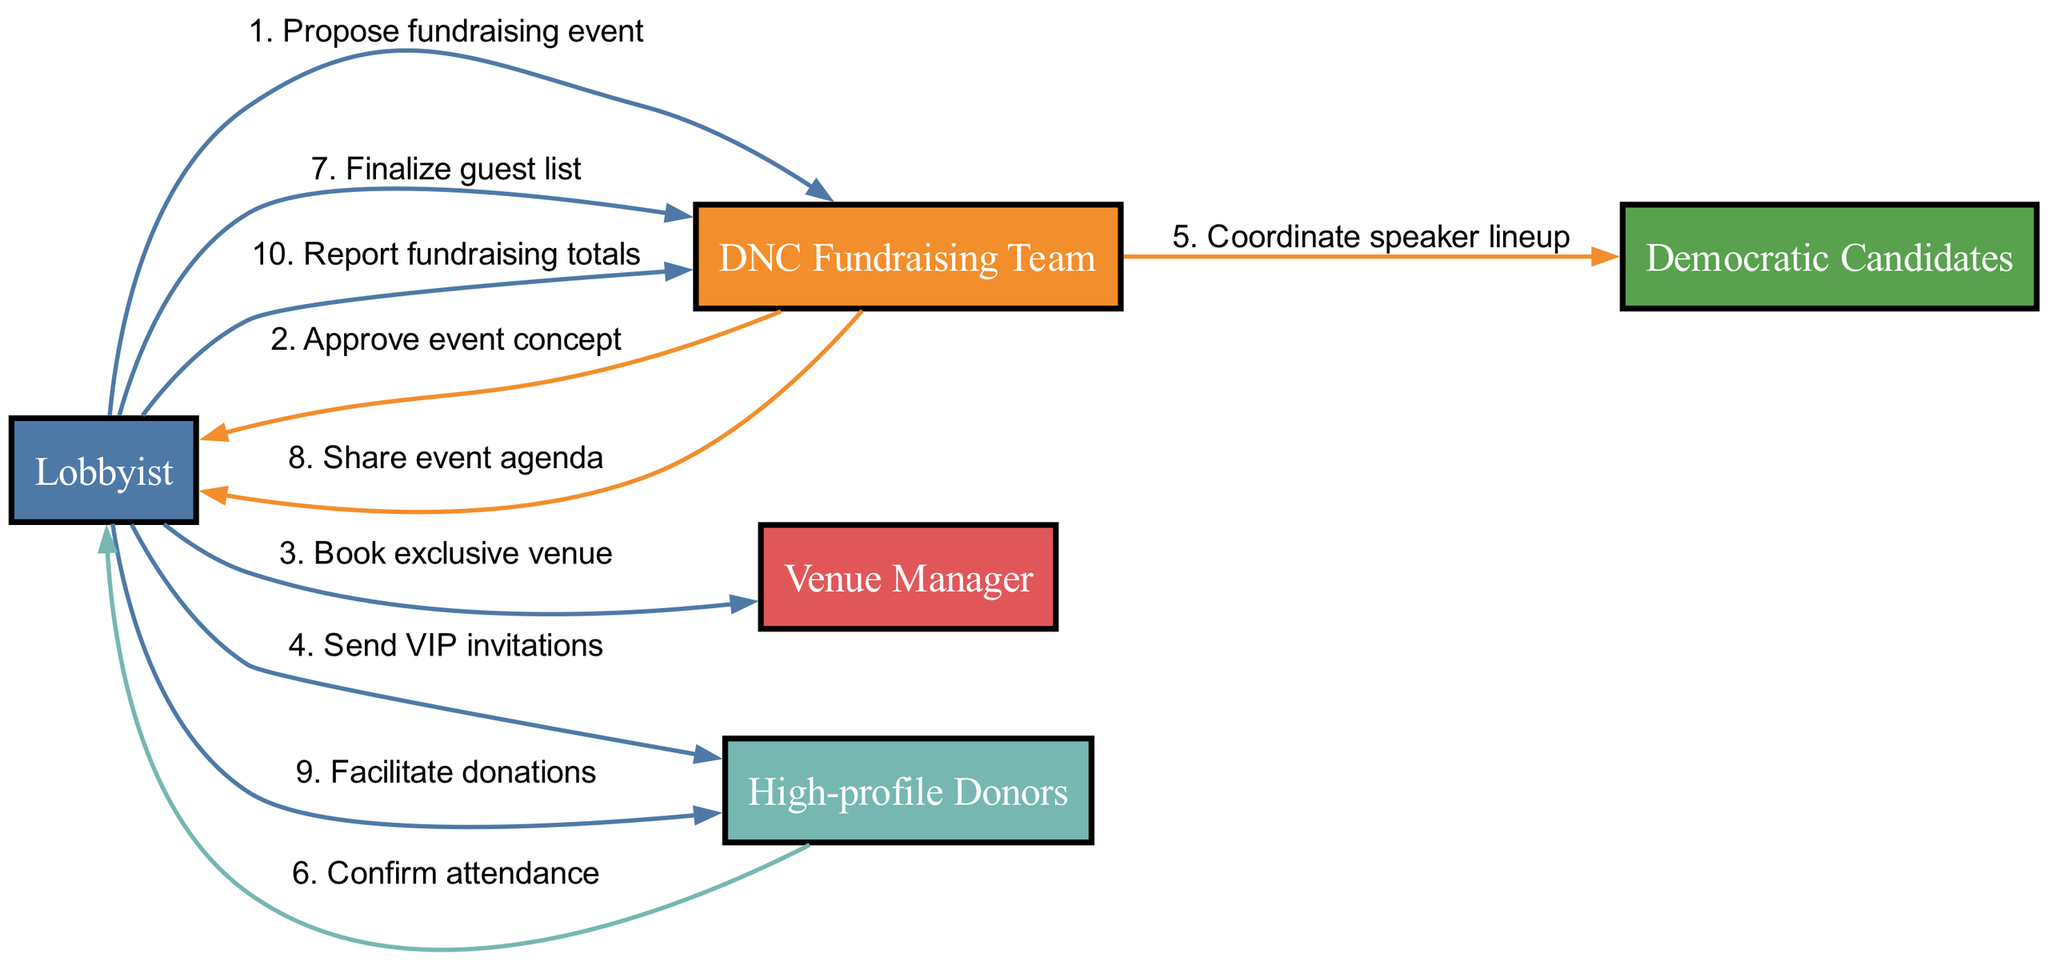What is the first message in the sequence? The first message in the sequence is sent from the Lobbyist to the DNC Fundraising Team, with the content "Propose fundraising event." This is the first step in the diagram which initiates the fundraising event organization process.
Answer: Propose fundraising event Who confirms attendance? Attendance is confirmed by the High-profile Donors. They send a message back to the Lobbyist indicating their attendance after being invited to the event.
Answer: High-profile Donors How many actors are involved in the sequence? The diagram identifies a total of five distinct actors: Lobbyist, DNC Fundraising Team, Venue Manager, High-profile Donors, and Democratic Candidates. Therefore, counting all the unique roles gives us the total number of actors.
Answer: 5 What message is sent to the Democratic Candidates? The message sent to the Democratic Candidates is "Coordinate speaker lineup," which involves the DNC Fundraising Team reaching out to the candidates to arrange the order of speakers for the event.
Answer: Coordinate speaker lineup Which actor finalizes the guest list? The Lobbyist is responsible for finalizing the guest list, as indicated by the directed message in the sequence where the Lobbyist interacts with the DNC Fundraising Team about this task.
Answer: Lobbyist What is the last message in the sequence? The last message in the sequence is "Report fundraising totals," which the Lobbyist sends to the DNC Fundraising Team. This indicates the completion of the fundraising efforts following the event.
Answer: Report fundraising totals What is the relationship between the Lobbyist and High-profile Donors? The relationship involves the Lobbyist sending VIP invitations to the High-profile Donors and later facilitating donations from them, indicating a communication and transactional exchange in the fundraising process.
Answer: Communication and transaction How many total messages are sent in the sequence? The sequence contains a total of ten messages. By carefully counting each directed message shown in the diagram, we arrive at this total.
Answer: 10 What does the DNC Fundraising Team share with the Lobbyist? The DNC Fundraising Team shares the event agenda with the Lobbyist, indicating the planned order of events for the fundraising occasion.
Answer: Event agenda 